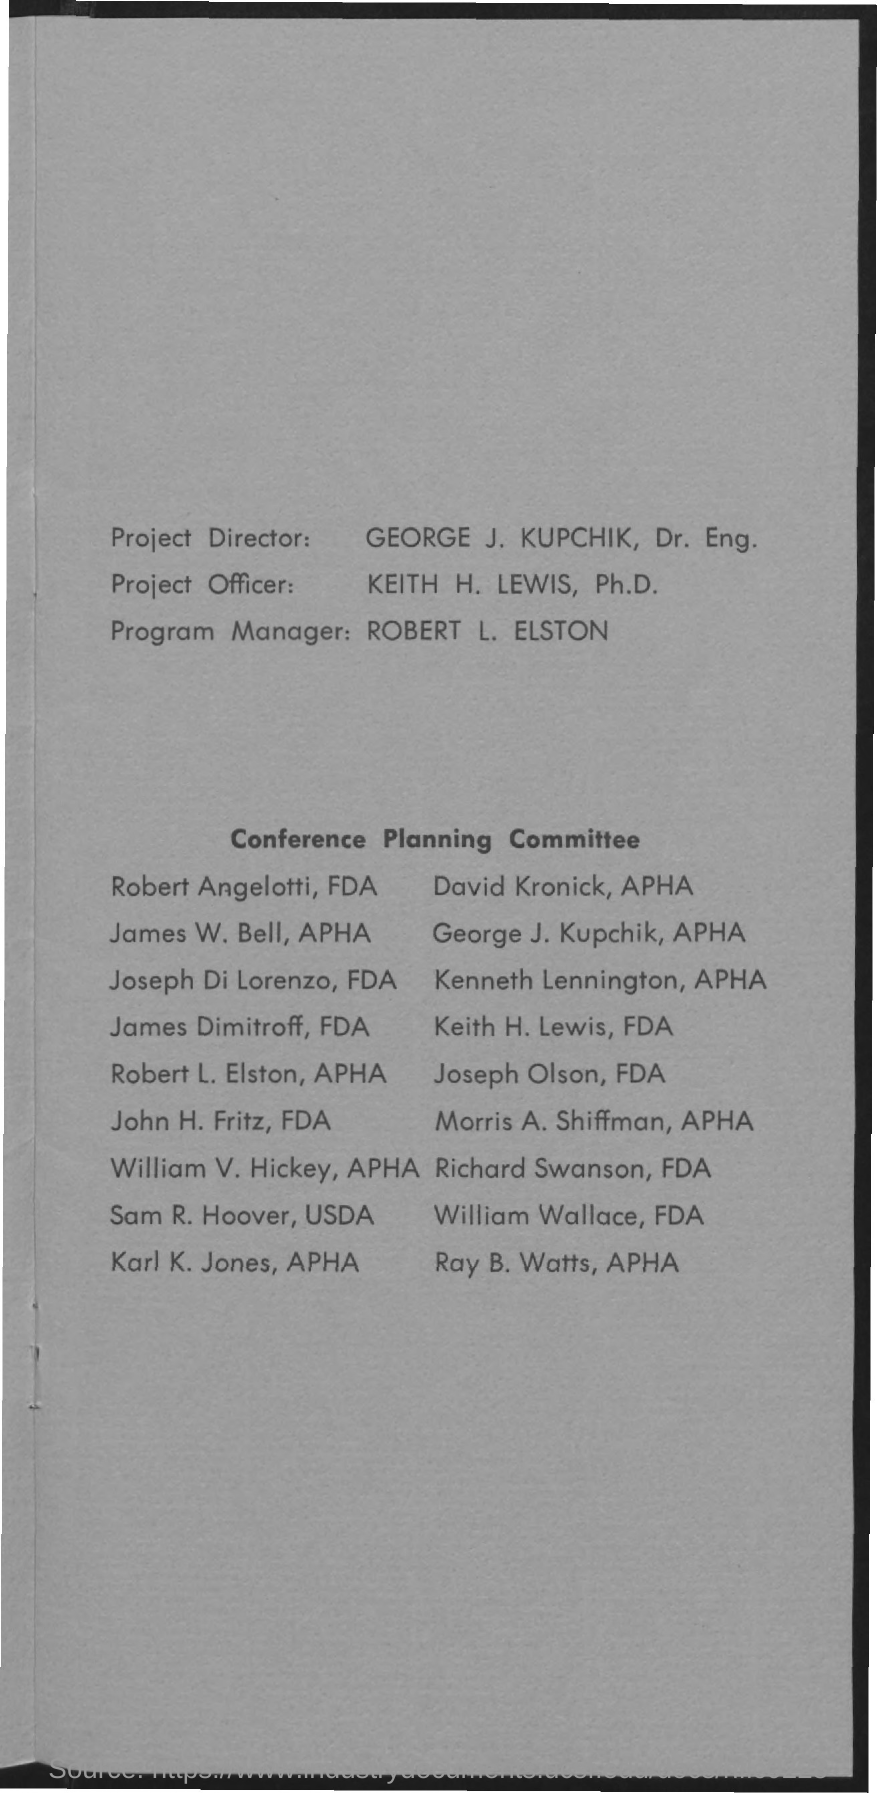List a handful of essential elements in this visual. The Program Manager is named Robert L. Elston. Keith H. Lewis is the project officer. 